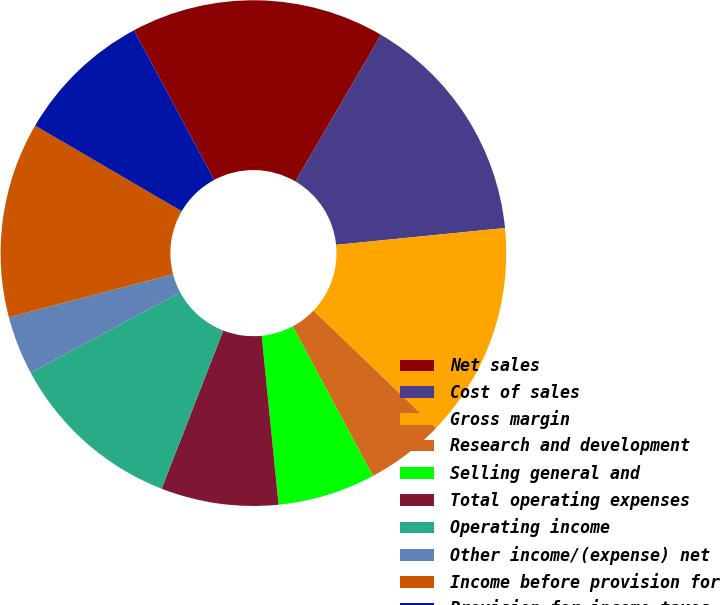Convert chart. <chart><loc_0><loc_0><loc_500><loc_500><pie_chart><fcel>Net sales<fcel>Cost of sales<fcel>Gross margin<fcel>Research and development<fcel>Selling general and<fcel>Total operating expenses<fcel>Operating income<fcel>Other income/(expense) net<fcel>Income before provision for<fcel>Provision for income taxes<nl><fcel>16.25%<fcel>15.0%<fcel>13.75%<fcel>5.0%<fcel>6.25%<fcel>7.5%<fcel>11.25%<fcel>3.75%<fcel>12.5%<fcel>8.75%<nl></chart> 